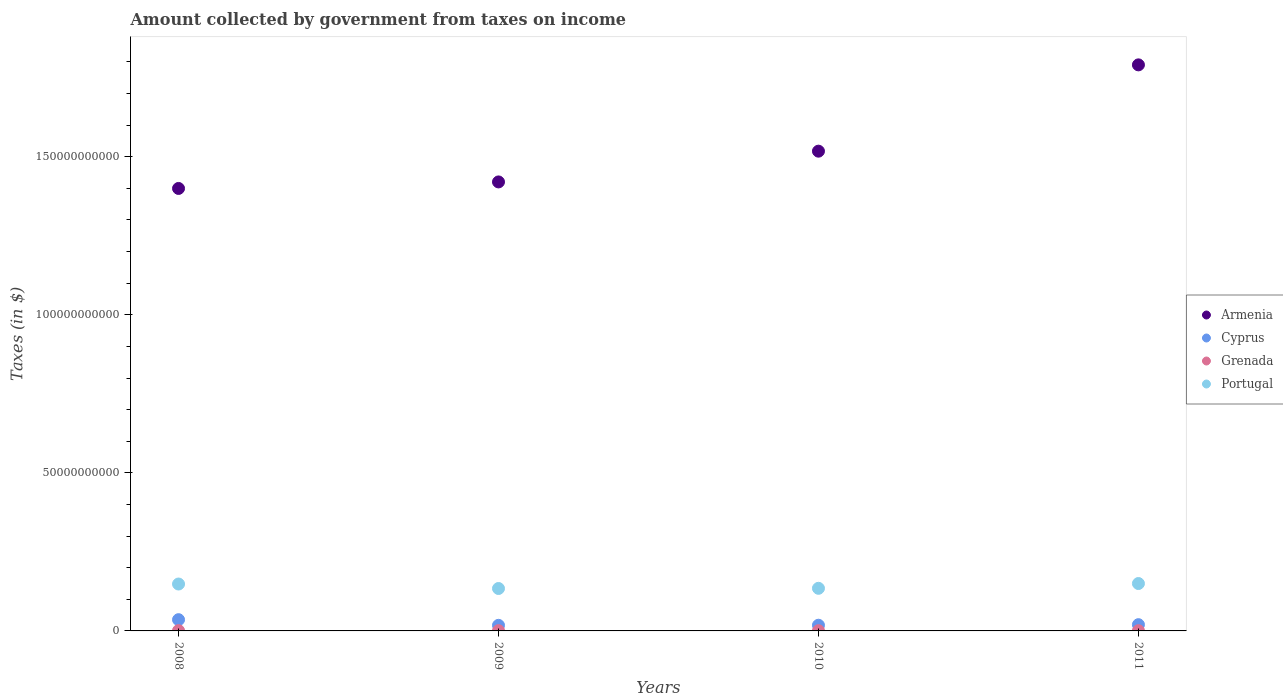How many different coloured dotlines are there?
Your response must be concise. 4. Is the number of dotlines equal to the number of legend labels?
Provide a short and direct response. Yes. What is the amount collected by government from taxes on income in Cyprus in 2008?
Provide a succinct answer. 3.56e+09. Across all years, what is the maximum amount collected by government from taxes on income in Cyprus?
Provide a short and direct response. 3.56e+09. Across all years, what is the minimum amount collected by government from taxes on income in Armenia?
Your response must be concise. 1.40e+11. In which year was the amount collected by government from taxes on income in Cyprus maximum?
Provide a succinct answer. 2008. What is the total amount collected by government from taxes on income in Portugal in the graph?
Ensure brevity in your answer.  5.67e+1. What is the difference between the amount collected by government from taxes on income in Portugal in 2009 and that in 2010?
Your response must be concise. -6.13e+07. What is the difference between the amount collected by government from taxes on income in Grenada in 2011 and the amount collected by government from taxes on income in Cyprus in 2008?
Keep it short and to the point. -3.48e+09. What is the average amount collected by government from taxes on income in Grenada per year?
Offer a very short reply. 8.22e+07. In the year 2010, what is the difference between the amount collected by government from taxes on income in Grenada and amount collected by government from taxes on income in Armenia?
Offer a terse response. -1.52e+11. What is the ratio of the amount collected by government from taxes on income in Portugal in 2010 to that in 2011?
Offer a terse response. 0.9. Is the amount collected by government from taxes on income in Portugal in 2009 less than that in 2010?
Make the answer very short. Yes. Is the difference between the amount collected by government from taxes on income in Grenada in 2008 and 2011 greater than the difference between the amount collected by government from taxes on income in Armenia in 2008 and 2011?
Offer a very short reply. Yes. What is the difference between the highest and the second highest amount collected by government from taxes on income in Portugal?
Provide a succinct answer. 1.55e+08. What is the difference between the highest and the lowest amount collected by government from taxes on income in Grenada?
Provide a succinct answer. 2.14e+07. Is it the case that in every year, the sum of the amount collected by government from taxes on income in Cyprus and amount collected by government from taxes on income in Portugal  is greater than the sum of amount collected by government from taxes on income in Grenada and amount collected by government from taxes on income in Armenia?
Your response must be concise. No. Is it the case that in every year, the sum of the amount collected by government from taxes on income in Armenia and amount collected by government from taxes on income in Portugal  is greater than the amount collected by government from taxes on income in Grenada?
Offer a terse response. Yes. Does the amount collected by government from taxes on income in Portugal monotonically increase over the years?
Make the answer very short. No. Is the amount collected by government from taxes on income in Cyprus strictly greater than the amount collected by government from taxes on income in Grenada over the years?
Your response must be concise. Yes. Is the amount collected by government from taxes on income in Grenada strictly less than the amount collected by government from taxes on income in Portugal over the years?
Ensure brevity in your answer.  Yes. How many dotlines are there?
Your answer should be very brief. 4. How many years are there in the graph?
Offer a terse response. 4. What is the difference between two consecutive major ticks on the Y-axis?
Your answer should be very brief. 5.00e+1. Does the graph contain any zero values?
Ensure brevity in your answer.  No. Where does the legend appear in the graph?
Your answer should be very brief. Center right. What is the title of the graph?
Offer a terse response. Amount collected by government from taxes on income. Does "Poland" appear as one of the legend labels in the graph?
Keep it short and to the point. No. What is the label or title of the Y-axis?
Offer a terse response. Taxes (in $). What is the Taxes (in $) of Armenia in 2008?
Your answer should be compact. 1.40e+11. What is the Taxes (in $) of Cyprus in 2008?
Your answer should be very brief. 3.56e+09. What is the Taxes (in $) of Grenada in 2008?
Give a very brief answer. 9.46e+07. What is the Taxes (in $) of Portugal in 2008?
Keep it short and to the point. 1.48e+1. What is the Taxes (in $) in Armenia in 2009?
Your answer should be compact. 1.42e+11. What is the Taxes (in $) in Cyprus in 2009?
Offer a terse response. 1.77e+09. What is the Taxes (in $) of Grenada in 2009?
Ensure brevity in your answer.  8.72e+07. What is the Taxes (in $) of Portugal in 2009?
Your response must be concise. 1.34e+1. What is the Taxes (in $) of Armenia in 2010?
Provide a short and direct response. 1.52e+11. What is the Taxes (in $) in Cyprus in 2010?
Give a very brief answer. 1.80e+09. What is the Taxes (in $) in Grenada in 2010?
Offer a very short reply. 7.32e+07. What is the Taxes (in $) of Portugal in 2010?
Provide a short and direct response. 1.35e+1. What is the Taxes (in $) of Armenia in 2011?
Provide a short and direct response. 1.79e+11. What is the Taxes (in $) of Cyprus in 2011?
Make the answer very short. 1.97e+09. What is the Taxes (in $) of Grenada in 2011?
Your response must be concise. 7.39e+07. What is the Taxes (in $) in Portugal in 2011?
Offer a very short reply. 1.50e+1. Across all years, what is the maximum Taxes (in $) of Armenia?
Make the answer very short. 1.79e+11. Across all years, what is the maximum Taxes (in $) of Cyprus?
Your answer should be very brief. 3.56e+09. Across all years, what is the maximum Taxes (in $) in Grenada?
Offer a terse response. 9.46e+07. Across all years, what is the maximum Taxes (in $) of Portugal?
Make the answer very short. 1.50e+1. Across all years, what is the minimum Taxes (in $) of Armenia?
Give a very brief answer. 1.40e+11. Across all years, what is the minimum Taxes (in $) of Cyprus?
Give a very brief answer. 1.77e+09. Across all years, what is the minimum Taxes (in $) in Grenada?
Ensure brevity in your answer.  7.32e+07. Across all years, what is the minimum Taxes (in $) of Portugal?
Keep it short and to the point. 1.34e+1. What is the total Taxes (in $) in Armenia in the graph?
Offer a terse response. 6.13e+11. What is the total Taxes (in $) in Cyprus in the graph?
Your answer should be compact. 9.10e+09. What is the total Taxes (in $) in Grenada in the graph?
Your response must be concise. 3.29e+08. What is the total Taxes (in $) of Portugal in the graph?
Your answer should be compact. 5.67e+1. What is the difference between the Taxes (in $) in Armenia in 2008 and that in 2009?
Keep it short and to the point. -2.06e+09. What is the difference between the Taxes (in $) in Cyprus in 2008 and that in 2009?
Offer a terse response. 1.79e+09. What is the difference between the Taxes (in $) in Grenada in 2008 and that in 2009?
Offer a very short reply. 7.40e+06. What is the difference between the Taxes (in $) of Portugal in 2008 and that in 2009?
Provide a short and direct response. 1.42e+09. What is the difference between the Taxes (in $) in Armenia in 2008 and that in 2010?
Your answer should be compact. -1.18e+1. What is the difference between the Taxes (in $) in Cyprus in 2008 and that in 2010?
Provide a succinct answer. 1.76e+09. What is the difference between the Taxes (in $) in Grenada in 2008 and that in 2010?
Give a very brief answer. 2.14e+07. What is the difference between the Taxes (in $) in Portugal in 2008 and that in 2010?
Give a very brief answer. 1.36e+09. What is the difference between the Taxes (in $) in Armenia in 2008 and that in 2011?
Offer a very short reply. -3.91e+1. What is the difference between the Taxes (in $) in Cyprus in 2008 and that in 2011?
Your answer should be compact. 1.58e+09. What is the difference between the Taxes (in $) of Grenada in 2008 and that in 2011?
Your answer should be very brief. 2.07e+07. What is the difference between the Taxes (in $) in Portugal in 2008 and that in 2011?
Provide a succinct answer. -1.55e+08. What is the difference between the Taxes (in $) of Armenia in 2009 and that in 2010?
Offer a terse response. -9.73e+09. What is the difference between the Taxes (in $) of Cyprus in 2009 and that in 2010?
Give a very brief answer. -3.17e+07. What is the difference between the Taxes (in $) in Grenada in 2009 and that in 2010?
Provide a succinct answer. 1.40e+07. What is the difference between the Taxes (in $) in Portugal in 2009 and that in 2010?
Provide a succinct answer. -6.13e+07. What is the difference between the Taxes (in $) in Armenia in 2009 and that in 2011?
Make the answer very short. -3.70e+1. What is the difference between the Taxes (in $) in Cyprus in 2009 and that in 2011?
Offer a terse response. -2.07e+08. What is the difference between the Taxes (in $) in Grenada in 2009 and that in 2011?
Your answer should be compact. 1.33e+07. What is the difference between the Taxes (in $) of Portugal in 2009 and that in 2011?
Your response must be concise. -1.57e+09. What is the difference between the Taxes (in $) in Armenia in 2010 and that in 2011?
Make the answer very short. -2.73e+1. What is the difference between the Taxes (in $) in Cyprus in 2010 and that in 2011?
Keep it short and to the point. -1.76e+08. What is the difference between the Taxes (in $) of Grenada in 2010 and that in 2011?
Provide a succinct answer. -7.00e+05. What is the difference between the Taxes (in $) of Portugal in 2010 and that in 2011?
Offer a very short reply. -1.51e+09. What is the difference between the Taxes (in $) in Armenia in 2008 and the Taxes (in $) in Cyprus in 2009?
Ensure brevity in your answer.  1.38e+11. What is the difference between the Taxes (in $) of Armenia in 2008 and the Taxes (in $) of Grenada in 2009?
Make the answer very short. 1.40e+11. What is the difference between the Taxes (in $) in Armenia in 2008 and the Taxes (in $) in Portugal in 2009?
Offer a terse response. 1.27e+11. What is the difference between the Taxes (in $) of Cyprus in 2008 and the Taxes (in $) of Grenada in 2009?
Offer a terse response. 3.47e+09. What is the difference between the Taxes (in $) in Cyprus in 2008 and the Taxes (in $) in Portugal in 2009?
Provide a succinct answer. -9.86e+09. What is the difference between the Taxes (in $) of Grenada in 2008 and the Taxes (in $) of Portugal in 2009?
Give a very brief answer. -1.33e+1. What is the difference between the Taxes (in $) of Armenia in 2008 and the Taxes (in $) of Cyprus in 2010?
Your answer should be very brief. 1.38e+11. What is the difference between the Taxes (in $) of Armenia in 2008 and the Taxes (in $) of Grenada in 2010?
Provide a succinct answer. 1.40e+11. What is the difference between the Taxes (in $) in Armenia in 2008 and the Taxes (in $) in Portugal in 2010?
Your answer should be compact. 1.26e+11. What is the difference between the Taxes (in $) of Cyprus in 2008 and the Taxes (in $) of Grenada in 2010?
Offer a very short reply. 3.49e+09. What is the difference between the Taxes (in $) of Cyprus in 2008 and the Taxes (in $) of Portugal in 2010?
Provide a succinct answer. -9.92e+09. What is the difference between the Taxes (in $) of Grenada in 2008 and the Taxes (in $) of Portugal in 2010?
Your response must be concise. -1.34e+1. What is the difference between the Taxes (in $) of Armenia in 2008 and the Taxes (in $) of Cyprus in 2011?
Offer a terse response. 1.38e+11. What is the difference between the Taxes (in $) in Armenia in 2008 and the Taxes (in $) in Grenada in 2011?
Keep it short and to the point. 1.40e+11. What is the difference between the Taxes (in $) in Armenia in 2008 and the Taxes (in $) in Portugal in 2011?
Offer a very short reply. 1.25e+11. What is the difference between the Taxes (in $) of Cyprus in 2008 and the Taxes (in $) of Grenada in 2011?
Provide a short and direct response. 3.48e+09. What is the difference between the Taxes (in $) in Cyprus in 2008 and the Taxes (in $) in Portugal in 2011?
Provide a succinct answer. -1.14e+1. What is the difference between the Taxes (in $) in Grenada in 2008 and the Taxes (in $) in Portugal in 2011?
Provide a short and direct response. -1.49e+1. What is the difference between the Taxes (in $) in Armenia in 2009 and the Taxes (in $) in Cyprus in 2010?
Give a very brief answer. 1.40e+11. What is the difference between the Taxes (in $) in Armenia in 2009 and the Taxes (in $) in Grenada in 2010?
Keep it short and to the point. 1.42e+11. What is the difference between the Taxes (in $) in Armenia in 2009 and the Taxes (in $) in Portugal in 2010?
Provide a short and direct response. 1.29e+11. What is the difference between the Taxes (in $) in Cyprus in 2009 and the Taxes (in $) in Grenada in 2010?
Make the answer very short. 1.69e+09. What is the difference between the Taxes (in $) of Cyprus in 2009 and the Taxes (in $) of Portugal in 2010?
Provide a succinct answer. -1.17e+1. What is the difference between the Taxes (in $) in Grenada in 2009 and the Taxes (in $) in Portugal in 2010?
Your answer should be compact. -1.34e+1. What is the difference between the Taxes (in $) in Armenia in 2009 and the Taxes (in $) in Cyprus in 2011?
Your answer should be very brief. 1.40e+11. What is the difference between the Taxes (in $) in Armenia in 2009 and the Taxes (in $) in Grenada in 2011?
Provide a short and direct response. 1.42e+11. What is the difference between the Taxes (in $) of Armenia in 2009 and the Taxes (in $) of Portugal in 2011?
Offer a terse response. 1.27e+11. What is the difference between the Taxes (in $) of Cyprus in 2009 and the Taxes (in $) of Grenada in 2011?
Your answer should be very brief. 1.69e+09. What is the difference between the Taxes (in $) in Cyprus in 2009 and the Taxes (in $) in Portugal in 2011?
Give a very brief answer. -1.32e+1. What is the difference between the Taxes (in $) of Grenada in 2009 and the Taxes (in $) of Portugal in 2011?
Your response must be concise. -1.49e+1. What is the difference between the Taxes (in $) in Armenia in 2010 and the Taxes (in $) in Cyprus in 2011?
Ensure brevity in your answer.  1.50e+11. What is the difference between the Taxes (in $) of Armenia in 2010 and the Taxes (in $) of Grenada in 2011?
Your response must be concise. 1.52e+11. What is the difference between the Taxes (in $) of Armenia in 2010 and the Taxes (in $) of Portugal in 2011?
Your answer should be compact. 1.37e+11. What is the difference between the Taxes (in $) of Cyprus in 2010 and the Taxes (in $) of Grenada in 2011?
Give a very brief answer. 1.73e+09. What is the difference between the Taxes (in $) of Cyprus in 2010 and the Taxes (in $) of Portugal in 2011?
Your answer should be very brief. -1.32e+1. What is the difference between the Taxes (in $) in Grenada in 2010 and the Taxes (in $) in Portugal in 2011?
Your answer should be very brief. -1.49e+1. What is the average Taxes (in $) of Armenia per year?
Offer a very short reply. 1.53e+11. What is the average Taxes (in $) of Cyprus per year?
Keep it short and to the point. 2.27e+09. What is the average Taxes (in $) of Grenada per year?
Ensure brevity in your answer.  8.22e+07. What is the average Taxes (in $) in Portugal per year?
Ensure brevity in your answer.  1.42e+1. In the year 2008, what is the difference between the Taxes (in $) of Armenia and Taxes (in $) of Cyprus?
Your answer should be very brief. 1.36e+11. In the year 2008, what is the difference between the Taxes (in $) in Armenia and Taxes (in $) in Grenada?
Ensure brevity in your answer.  1.40e+11. In the year 2008, what is the difference between the Taxes (in $) in Armenia and Taxes (in $) in Portugal?
Provide a succinct answer. 1.25e+11. In the year 2008, what is the difference between the Taxes (in $) in Cyprus and Taxes (in $) in Grenada?
Ensure brevity in your answer.  3.46e+09. In the year 2008, what is the difference between the Taxes (in $) in Cyprus and Taxes (in $) in Portugal?
Your answer should be very brief. -1.13e+1. In the year 2008, what is the difference between the Taxes (in $) in Grenada and Taxes (in $) in Portugal?
Your answer should be compact. -1.47e+1. In the year 2009, what is the difference between the Taxes (in $) in Armenia and Taxes (in $) in Cyprus?
Make the answer very short. 1.40e+11. In the year 2009, what is the difference between the Taxes (in $) in Armenia and Taxes (in $) in Grenada?
Offer a terse response. 1.42e+11. In the year 2009, what is the difference between the Taxes (in $) in Armenia and Taxes (in $) in Portugal?
Make the answer very short. 1.29e+11. In the year 2009, what is the difference between the Taxes (in $) in Cyprus and Taxes (in $) in Grenada?
Your answer should be compact. 1.68e+09. In the year 2009, what is the difference between the Taxes (in $) of Cyprus and Taxes (in $) of Portugal?
Your response must be concise. -1.17e+1. In the year 2009, what is the difference between the Taxes (in $) of Grenada and Taxes (in $) of Portugal?
Ensure brevity in your answer.  -1.33e+1. In the year 2010, what is the difference between the Taxes (in $) of Armenia and Taxes (in $) of Cyprus?
Give a very brief answer. 1.50e+11. In the year 2010, what is the difference between the Taxes (in $) in Armenia and Taxes (in $) in Grenada?
Your answer should be very brief. 1.52e+11. In the year 2010, what is the difference between the Taxes (in $) of Armenia and Taxes (in $) of Portugal?
Provide a short and direct response. 1.38e+11. In the year 2010, what is the difference between the Taxes (in $) in Cyprus and Taxes (in $) in Grenada?
Provide a short and direct response. 1.73e+09. In the year 2010, what is the difference between the Taxes (in $) of Cyprus and Taxes (in $) of Portugal?
Keep it short and to the point. -1.17e+1. In the year 2010, what is the difference between the Taxes (in $) in Grenada and Taxes (in $) in Portugal?
Your response must be concise. -1.34e+1. In the year 2011, what is the difference between the Taxes (in $) in Armenia and Taxes (in $) in Cyprus?
Your response must be concise. 1.77e+11. In the year 2011, what is the difference between the Taxes (in $) of Armenia and Taxes (in $) of Grenada?
Keep it short and to the point. 1.79e+11. In the year 2011, what is the difference between the Taxes (in $) of Armenia and Taxes (in $) of Portugal?
Ensure brevity in your answer.  1.64e+11. In the year 2011, what is the difference between the Taxes (in $) in Cyprus and Taxes (in $) in Grenada?
Give a very brief answer. 1.90e+09. In the year 2011, what is the difference between the Taxes (in $) of Cyprus and Taxes (in $) of Portugal?
Your answer should be very brief. -1.30e+1. In the year 2011, what is the difference between the Taxes (in $) of Grenada and Taxes (in $) of Portugal?
Provide a short and direct response. -1.49e+1. What is the ratio of the Taxes (in $) in Armenia in 2008 to that in 2009?
Make the answer very short. 0.99. What is the ratio of the Taxes (in $) in Cyprus in 2008 to that in 2009?
Your response must be concise. 2.01. What is the ratio of the Taxes (in $) in Grenada in 2008 to that in 2009?
Provide a short and direct response. 1.08. What is the ratio of the Taxes (in $) in Portugal in 2008 to that in 2009?
Your response must be concise. 1.11. What is the ratio of the Taxes (in $) in Armenia in 2008 to that in 2010?
Offer a very short reply. 0.92. What is the ratio of the Taxes (in $) of Cyprus in 2008 to that in 2010?
Your response must be concise. 1.98. What is the ratio of the Taxes (in $) in Grenada in 2008 to that in 2010?
Make the answer very short. 1.29. What is the ratio of the Taxes (in $) in Portugal in 2008 to that in 2010?
Offer a terse response. 1.1. What is the ratio of the Taxes (in $) in Armenia in 2008 to that in 2011?
Provide a succinct answer. 0.78. What is the ratio of the Taxes (in $) of Cyprus in 2008 to that in 2011?
Give a very brief answer. 1.8. What is the ratio of the Taxes (in $) in Grenada in 2008 to that in 2011?
Your answer should be compact. 1.28. What is the ratio of the Taxes (in $) of Portugal in 2008 to that in 2011?
Offer a very short reply. 0.99. What is the ratio of the Taxes (in $) in Armenia in 2009 to that in 2010?
Your response must be concise. 0.94. What is the ratio of the Taxes (in $) in Cyprus in 2009 to that in 2010?
Offer a very short reply. 0.98. What is the ratio of the Taxes (in $) in Grenada in 2009 to that in 2010?
Offer a very short reply. 1.19. What is the ratio of the Taxes (in $) in Armenia in 2009 to that in 2011?
Your answer should be very brief. 0.79. What is the ratio of the Taxes (in $) of Cyprus in 2009 to that in 2011?
Your answer should be very brief. 0.9. What is the ratio of the Taxes (in $) in Grenada in 2009 to that in 2011?
Offer a terse response. 1.18. What is the ratio of the Taxes (in $) of Portugal in 2009 to that in 2011?
Your answer should be very brief. 0.9. What is the ratio of the Taxes (in $) in Armenia in 2010 to that in 2011?
Keep it short and to the point. 0.85. What is the ratio of the Taxes (in $) of Cyprus in 2010 to that in 2011?
Your response must be concise. 0.91. What is the ratio of the Taxes (in $) of Grenada in 2010 to that in 2011?
Your answer should be compact. 0.99. What is the ratio of the Taxes (in $) in Portugal in 2010 to that in 2011?
Your response must be concise. 0.9. What is the difference between the highest and the second highest Taxes (in $) of Armenia?
Your response must be concise. 2.73e+1. What is the difference between the highest and the second highest Taxes (in $) of Cyprus?
Ensure brevity in your answer.  1.58e+09. What is the difference between the highest and the second highest Taxes (in $) of Grenada?
Keep it short and to the point. 7.40e+06. What is the difference between the highest and the second highest Taxes (in $) of Portugal?
Offer a very short reply. 1.55e+08. What is the difference between the highest and the lowest Taxes (in $) of Armenia?
Ensure brevity in your answer.  3.91e+1. What is the difference between the highest and the lowest Taxes (in $) of Cyprus?
Provide a short and direct response. 1.79e+09. What is the difference between the highest and the lowest Taxes (in $) in Grenada?
Provide a short and direct response. 2.14e+07. What is the difference between the highest and the lowest Taxes (in $) in Portugal?
Ensure brevity in your answer.  1.57e+09. 